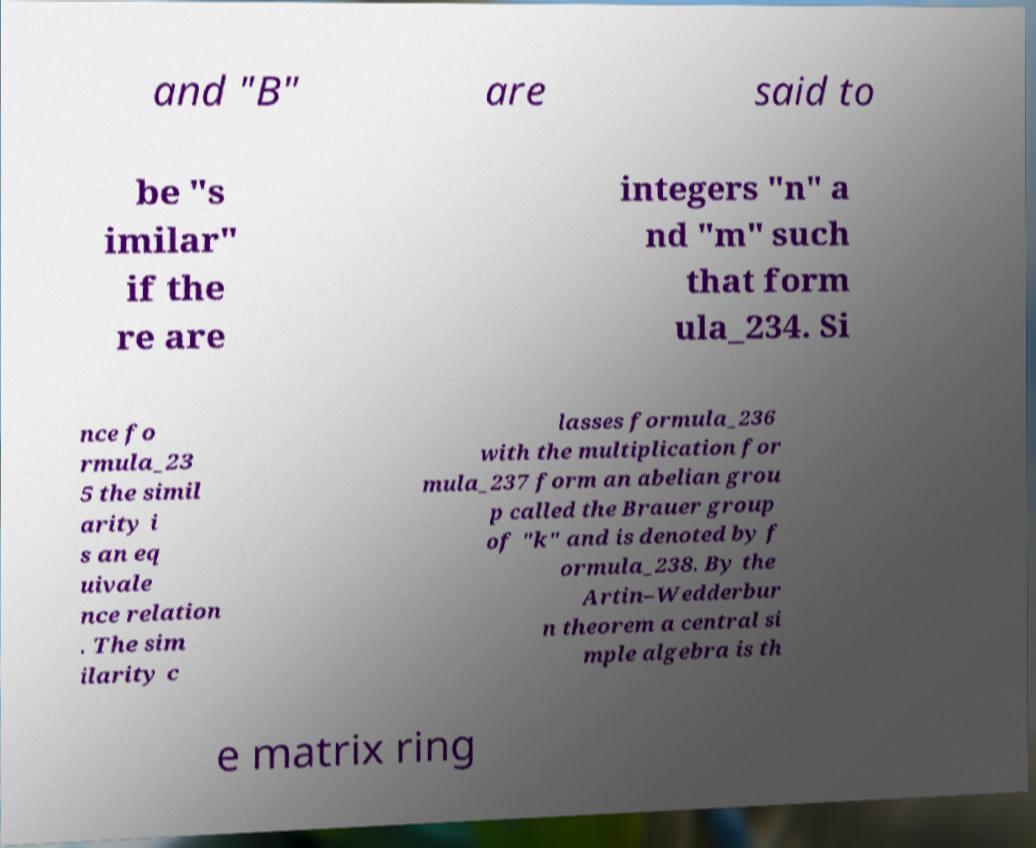Can you read and provide the text displayed in the image?This photo seems to have some interesting text. Can you extract and type it out for me? and "B" are said to be "s imilar" if the re are integers "n" a nd "m" such that form ula_234. Si nce fo rmula_23 5 the simil arity i s an eq uivale nce relation . The sim ilarity c lasses formula_236 with the multiplication for mula_237 form an abelian grou p called the Brauer group of "k" and is denoted by f ormula_238. By the Artin–Wedderbur n theorem a central si mple algebra is th e matrix ring 